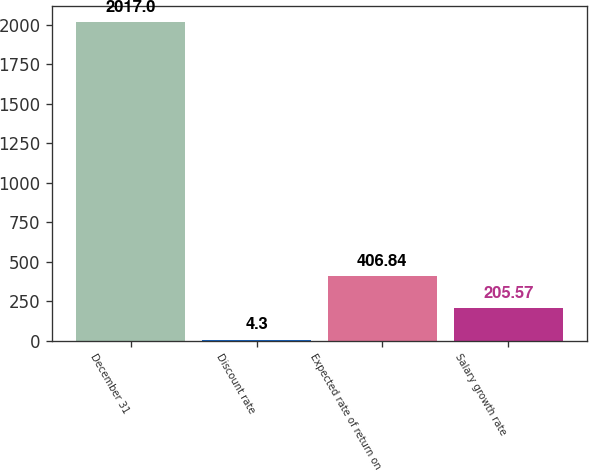Convert chart. <chart><loc_0><loc_0><loc_500><loc_500><bar_chart><fcel>December 31<fcel>Discount rate<fcel>Expected rate of return on<fcel>Salary growth rate<nl><fcel>2017<fcel>4.3<fcel>406.84<fcel>205.57<nl></chart> 